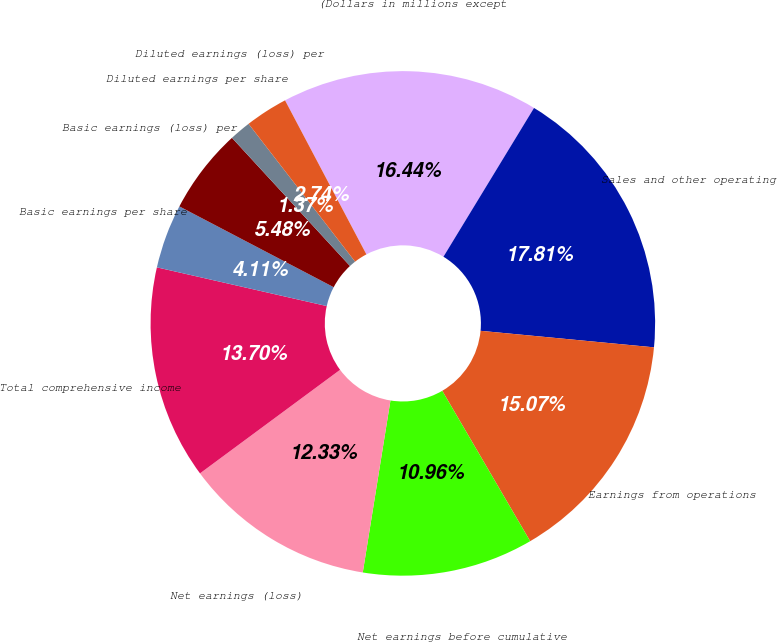<chart> <loc_0><loc_0><loc_500><loc_500><pie_chart><fcel>(Dollars in millions except<fcel>Sales and other operating<fcel>Earnings from operations<fcel>Net earnings before cumulative<fcel>Net earnings (loss)<fcel>Total comprehensive income<fcel>Basic earnings per share<fcel>Basic earnings (loss) per<fcel>Diluted earnings per share<fcel>Diluted earnings (loss) per<nl><fcel>16.44%<fcel>17.81%<fcel>15.07%<fcel>10.96%<fcel>12.33%<fcel>13.7%<fcel>4.11%<fcel>5.48%<fcel>1.37%<fcel>2.74%<nl></chart> 